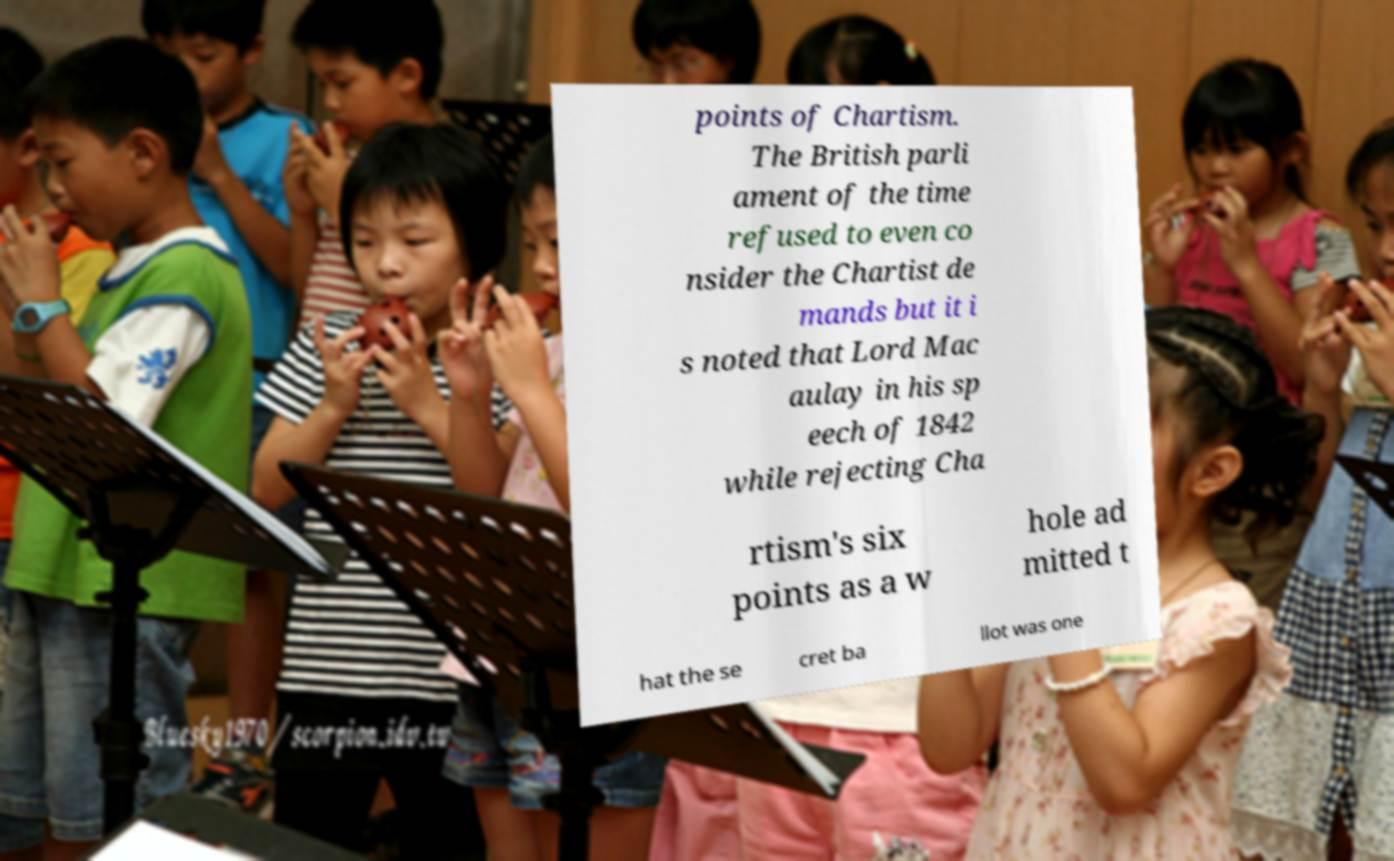Could you extract and type out the text from this image? points of Chartism. The British parli ament of the time refused to even co nsider the Chartist de mands but it i s noted that Lord Mac aulay in his sp eech of 1842 while rejecting Cha rtism's six points as a w hole ad mitted t hat the se cret ba llot was one 